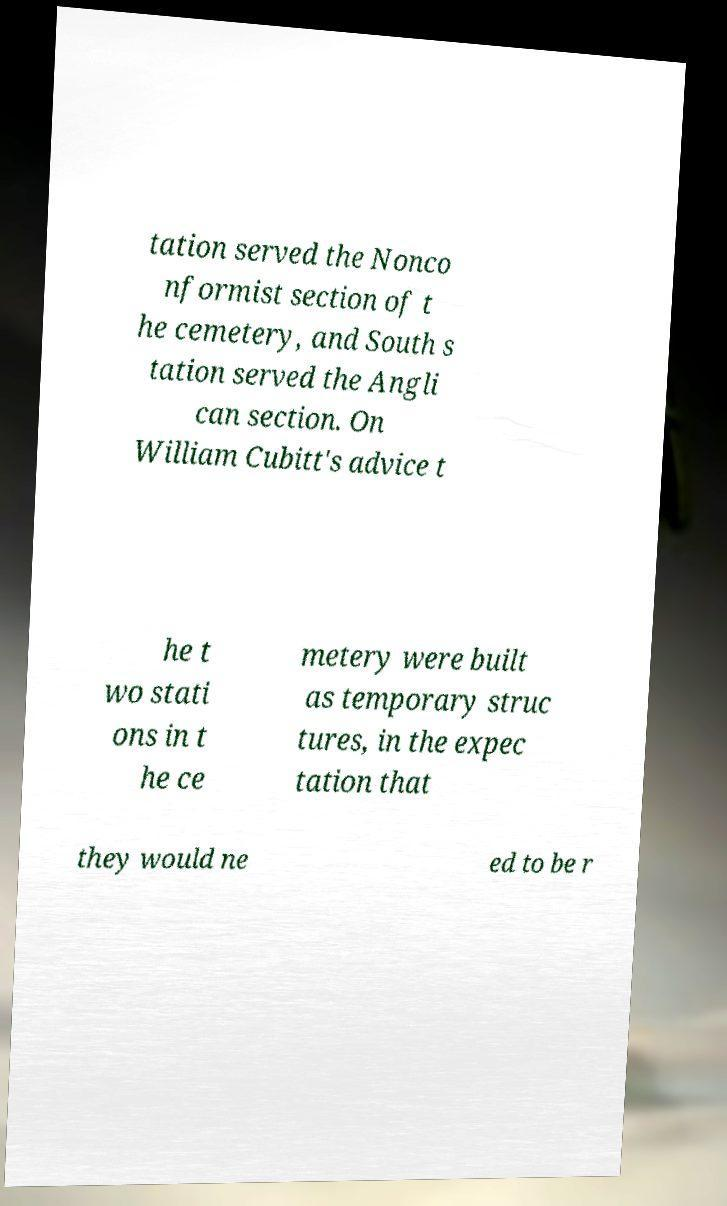Please read and relay the text visible in this image. What does it say? tation served the Nonco nformist section of t he cemetery, and South s tation served the Angli can section. On William Cubitt's advice t he t wo stati ons in t he ce metery were built as temporary struc tures, in the expec tation that they would ne ed to be r 